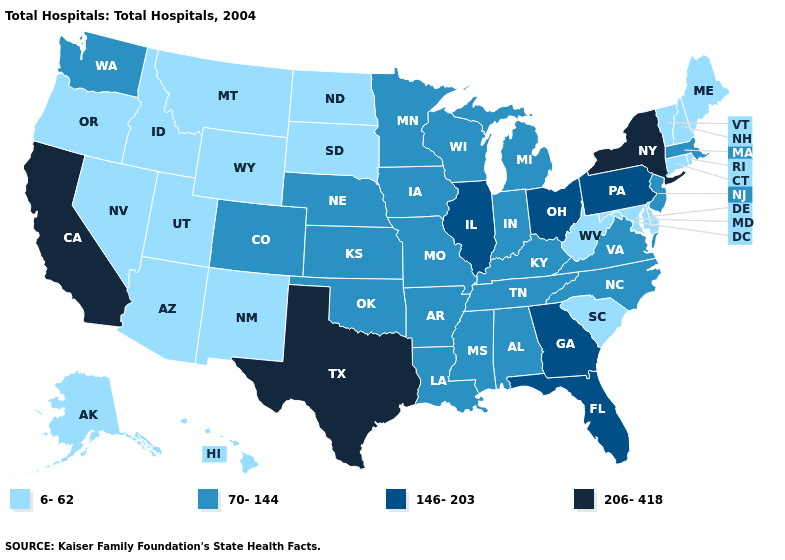Which states have the highest value in the USA?
Answer briefly. California, New York, Texas. Does the first symbol in the legend represent the smallest category?
Give a very brief answer. Yes. Does the map have missing data?
Be succinct. No. Name the states that have a value in the range 146-203?
Write a very short answer. Florida, Georgia, Illinois, Ohio, Pennsylvania. What is the value of Maryland?
Quick response, please. 6-62. Does Texas have the lowest value in the USA?
Concise answer only. No. Which states have the lowest value in the Northeast?
Be succinct. Connecticut, Maine, New Hampshire, Rhode Island, Vermont. What is the highest value in the West ?
Write a very short answer. 206-418. What is the lowest value in states that border Virginia?
Answer briefly. 6-62. Does California have the highest value in the USA?
Answer briefly. Yes. What is the value of North Carolina?
Be succinct. 70-144. Does Pennsylvania have the lowest value in the Northeast?
Short answer required. No. What is the value of Wisconsin?
Answer briefly. 70-144. Does Connecticut have a higher value than Georgia?
Give a very brief answer. No. 